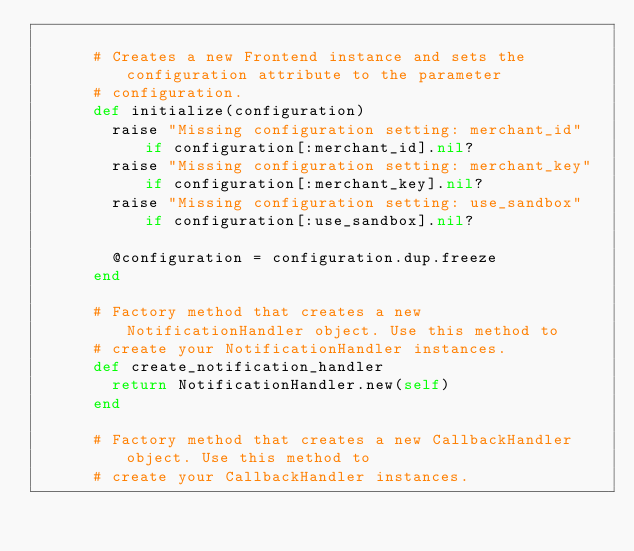<code> <loc_0><loc_0><loc_500><loc_500><_Ruby_>      
      # Creates a new Frontend instance and sets the configuration attribute to the parameter
      # configuration.
      def initialize(configuration)
        raise "Missing configuration setting: merchant_id"  if configuration[:merchant_id].nil?
        raise "Missing configuration setting: merchant_key" if configuration[:merchant_key].nil?
        raise "Missing configuration setting: use_sandbox"  if configuration[:use_sandbox].nil?
        
        @configuration = configuration.dup.freeze
      end
      
      # Factory method that creates a new NotificationHandler object. Use this method to
      # create your NotificationHandler instances.
      def create_notification_handler
        return NotificationHandler.new(self)
      end
      
      # Factory method that creates a new CallbackHandler object. Use this method to
      # create your CallbackHandler instances.</code> 